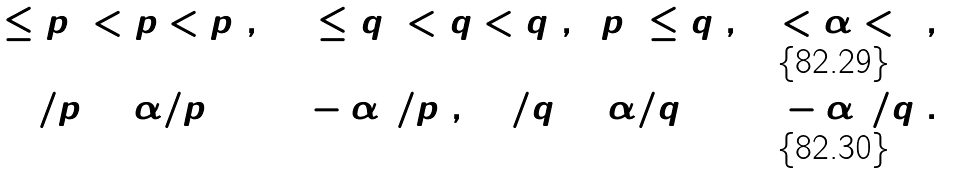<formula> <loc_0><loc_0><loc_500><loc_500>1 \leq p _ { 1 } < p < p _ { 2 } , \ \ 1 \leq q _ { 1 } < q < q _ { 2 } , \ \ p _ { 2 } \leq q _ { 2 } , \, 0 < \alpha < 1 , \\ 1 / p = \alpha / p _ { 1 } + ( 1 - \alpha ) / p _ { 2 } , \ \ 1 / q = \alpha / q _ { 1 } + ( 1 - \alpha ) / q _ { 2 } .</formula> 